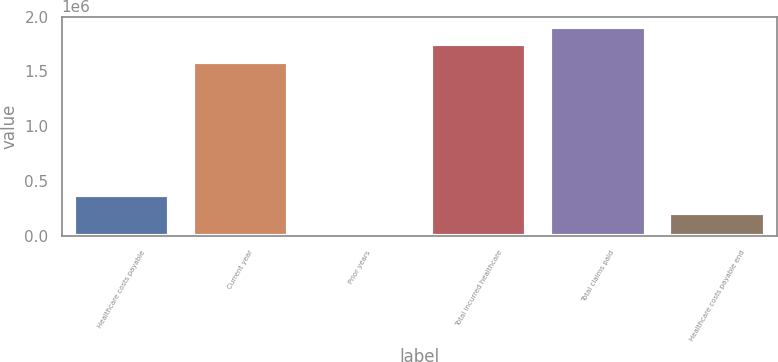<chart> <loc_0><loc_0><loc_500><loc_500><bar_chart><fcel>Healthcare costs payable<fcel>Current year<fcel>Prior years<fcel>Total incurred healthcare<fcel>Total claims paid<fcel>Healthcare costs payable end<nl><fcel>371521<fcel>1.58704e+06<fcel>1523<fcel>1.74592e+06<fcel>1.9048e+06<fcel>212641<nl></chart> 